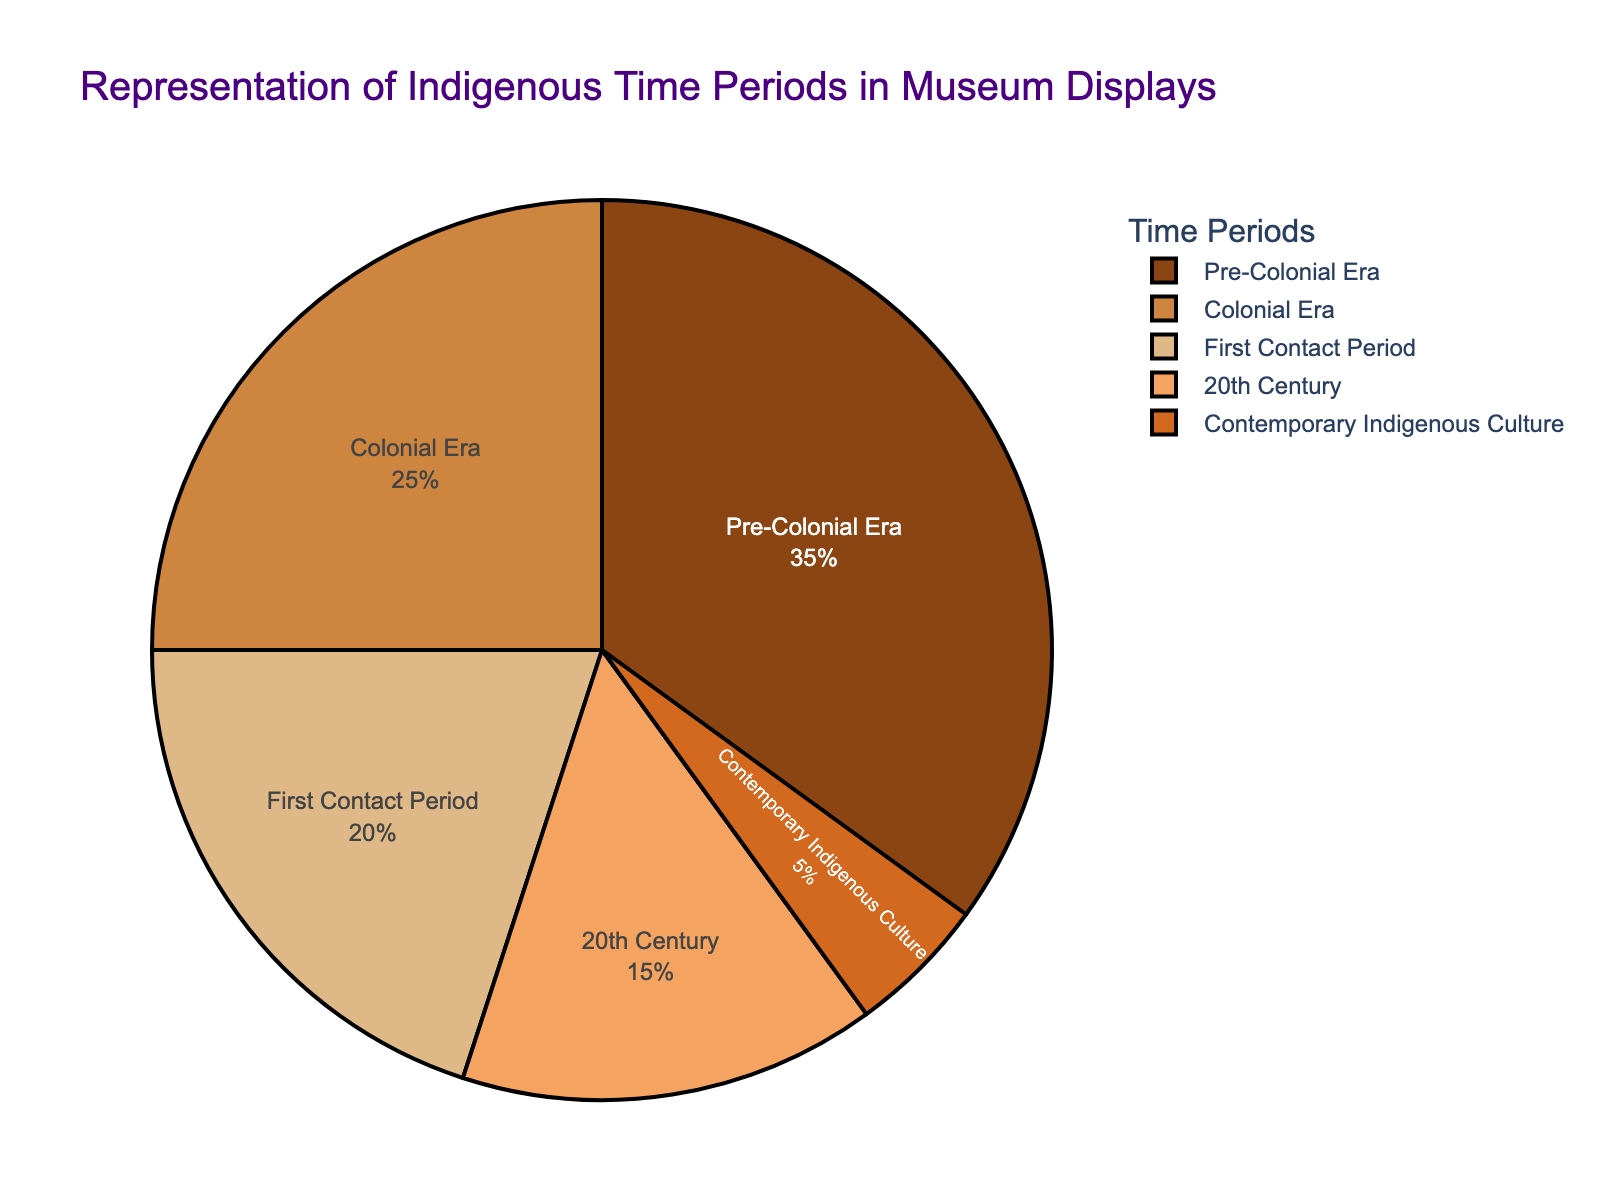How much more representation does the Pre-Colonial Era have compared to the Contemporary Indigenous Culture? The Pre-Colonial Era has 35% representation, while the Contemporary Indigenous Culture has only 5%. The difference is 35% - 5% = 30%.
Answer: 30% Which time period has the highest representation? Referring to the pie chart, the Pre-Colonial Era has the largest segment, representing 35% of the total.
Answer: Pre-Colonial Era What is the combined representation percentage of the First Contact Period and the Colonial Era? The First Contact Period represents 20%, and the Colonial Era accounts for 25%. Adding them together gives 20% + 25% = 45%.
Answer: 45% Is the representation of the 20th Century greater than, less than, or equal to the representation of the First Contact Period? The 20th Century has a representation of 15%, which is less than the First Contact Period's 20% as shown in the pie chart.
Answer: Less than Among the time periods, which one has the smallest representation in museum displays? The pie chart indicates that Contemporary Indigenous Culture has the smallest segment, representing 5% of the total.
Answer: Contemporary Indigenous Culture How does the representation of the Colonial Era compare to the Pre-Colonial Era and 20th Century combined? The Colonial Era has 25% representation. Pre-Colonial Era is 35% and the 20th Century is 15%. Combined, they sum up to 35% + 15% = 50%, which is greater than 25%.
Answer: Less than What is the total representation of time periods that happened before the 20th Century? Pre-Colonial Era (35%), First Contact Period (20%), and Colonial Era (25%) all happened before the 20th Century. Summing them gives 35% + 20% + 25% = 80%.
Answer: 80% What percentage of the total do the most and least represented periods add up to? The most represented period (Pre-Colonial Era) is 35%, and the least represented period (Contemporary Indigenous Culture) is 5%. Together they add up to 35% + 5% = 40%.
Answer: 40% If the museum decides to double the representation of Contemporary Indigenous Culture, what would its new percentage be? Doubling the current 5% representation of Contemporary Indigenous Culture would give 5% * 2 = 10%.
Answer: 10% 